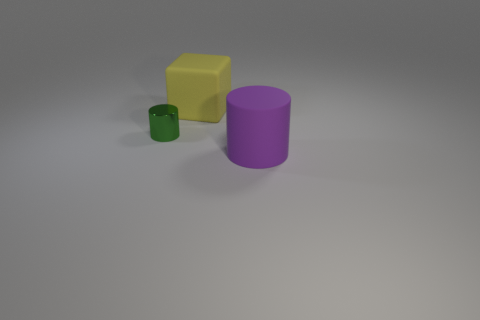Add 1 small gray objects. How many objects exist? 4 Subtract all green cylinders. How many cylinders are left? 1 Subtract all blocks. How many objects are left? 2 Subtract 1 cylinders. How many cylinders are left? 1 Subtract all large shiny cylinders. Subtract all big matte objects. How many objects are left? 1 Add 1 green shiny cylinders. How many green shiny cylinders are left? 2 Add 1 purple rubber cylinders. How many purple rubber cylinders exist? 2 Subtract 0 green balls. How many objects are left? 3 Subtract all yellow cylinders. Subtract all blue balls. How many cylinders are left? 2 Subtract all blue cubes. How many green cylinders are left? 1 